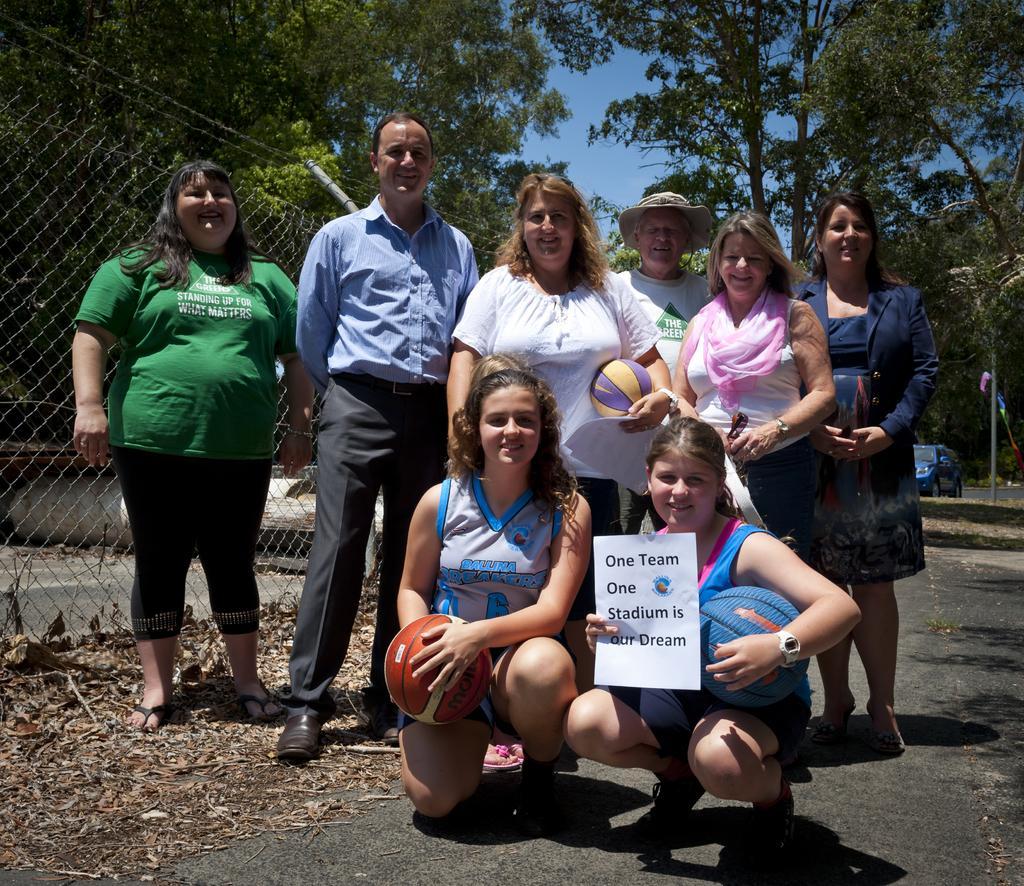In one or two sentences, can you explain what this image depicts? At the bottom of the image there are two ladies sitting. The girl sitting on the right is holding a paper and we can see balls in their hands. In the background there are people standing. On the left there is a mesh. In the background there are trees, car and sky. 